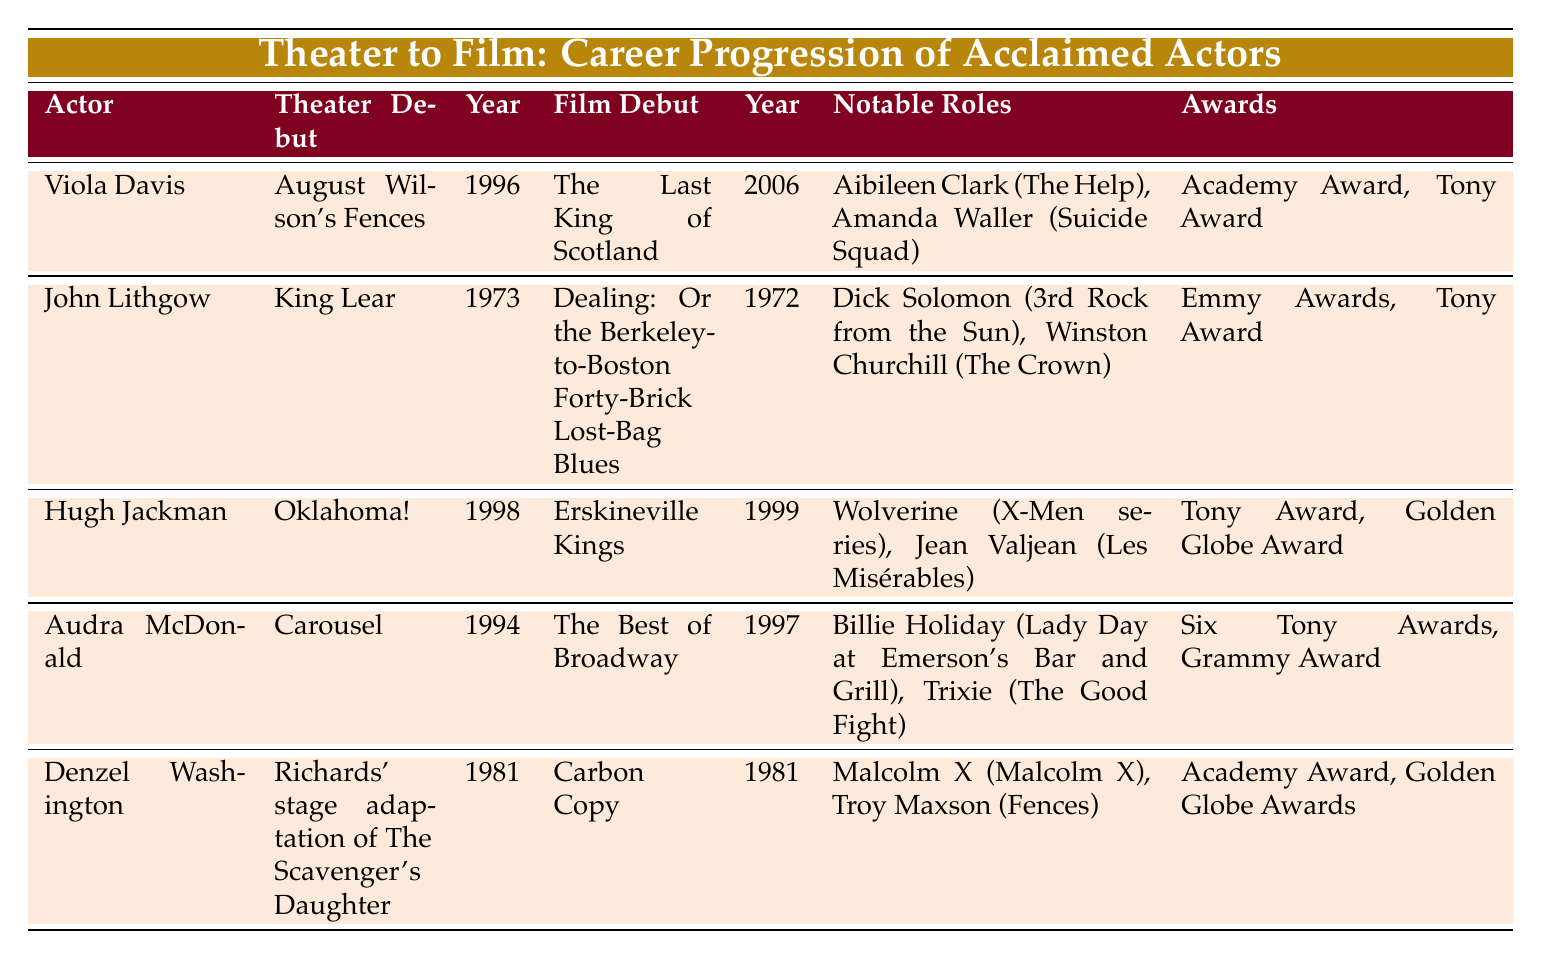What is the theater debut of Hugh Jackman? The table states that Hugh Jackman's theater debut was in "Oklahoma!"
Answer: Oklahoma! Which actor won an Academy Award for Best Supporting Actress? Viola Davis is the actor listed in the table who won an Academy Award for Best Supporting Actress.
Answer: Viola Davis How many years passed between Audra McDonald's theater debut and her film debut? Audra McDonald made her theater debut in 1994 and her film debut in 1997. The difference is 1997 - 1994 = 3 years.
Answer: 3 years Is it true that Denzel Washington's film debut occurred the same year as his theater debut? Yes, both his theater debut and film debut occurred in the year 1981.
Answer: Yes Which actor has the most awards listed? Audra McDonald has the most awards listed, including six Tony Awards and a Grammy Award.
Answer: Audra McDonald What is the notable role played by John Lithgow in "The Crown"? John Lithgow's notable role in "The Crown" is Winston Churchill, as mentioned in the table.
Answer: Winston Churchill What are the notable roles of Viola Davis? Viola Davis's notable roles are Aibileen Clark in "The Help" and Amanda Waller in "Suicide Squad."
Answer: Aibileen Clark, Amanda Waller How many total awards are represented by the actors in the table? Counting all the awards: Viola Davis (2), John Lithgow (2), Hugh Jackman (2), Audra McDonald (7), and Denzel Washington (2), which gives a total of 15 awards.
Answer: 15 awards Which actor's theater career began in 1981? Denzel Washington is the actor whose theater debut took place in 1981.
Answer: Denzel Washington 